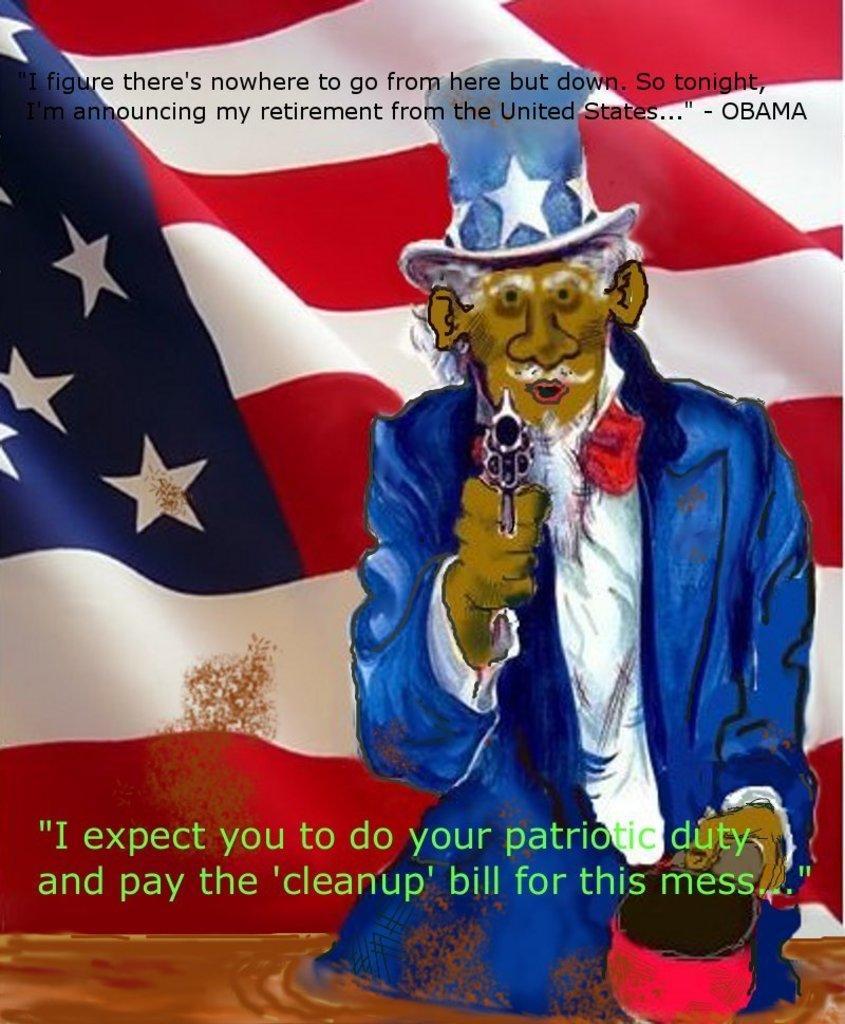Describe this image in one or two sentences. In this image there is a painting of a man wearing blue coat and hat. He is holding a gun. In the background there is flag. On the top and bottom there are some texts. 